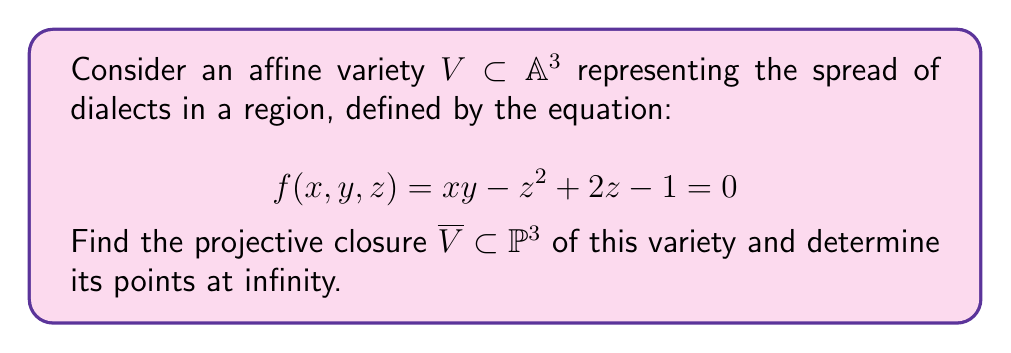Provide a solution to this math problem. To find the projective closure of the affine variety, we follow these steps:

1) First, we homogenize the equation by introducing a new variable $w$ and multiplying each term by the appropriate power of $w$ to make all terms have the same total degree:

   $$ F(X,Y,Z,W) = XY - Z^2 + 2ZW - W^2 = 0 $$

2) The projective closure $\overline{V}$ is defined by this homogeneous equation in $\mathbb{P}^3$.

3) To find the points at infinity, we set $W = 0$ in the homogeneous equation:

   $$ XY - Z^2 = 0 $$

4) This gives us a conic in the plane at infinity. We can parametrize this conic as:

   $$ [X:Y:Z:W] = [t^2 : 1 : t : 0] \text{ or } [1 : s^2 : s : 0] $$

   where $t$ and $s$ are parameters (and $t = 1/s$ when both are defined).

5) These points at infinity can be interpreted as the "ultimate spread" or "asymptotic behavior" of the dialects in the region, representing how the dialect variations extend to the farthest reaches of the locale.
Answer: $\overline{V}: XY - Z^2 + 2ZW - W^2 = 0$ in $\mathbb{P}^3$; Points at infinity: $[t^2:1:t:0]$ or $[1:s^2:s:0]$ 